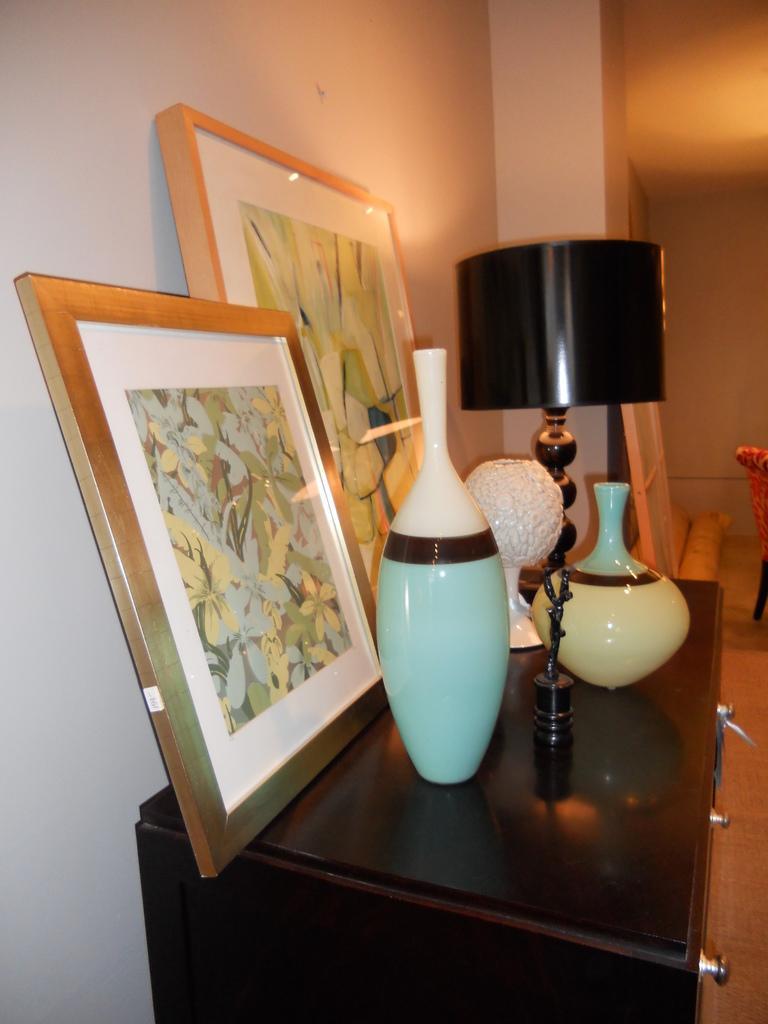Can you describe this image briefly? In this picture there is a table, with some shelf, there is a flower pot, a lamp, there is a photo frame placed on it and the background is of wall 